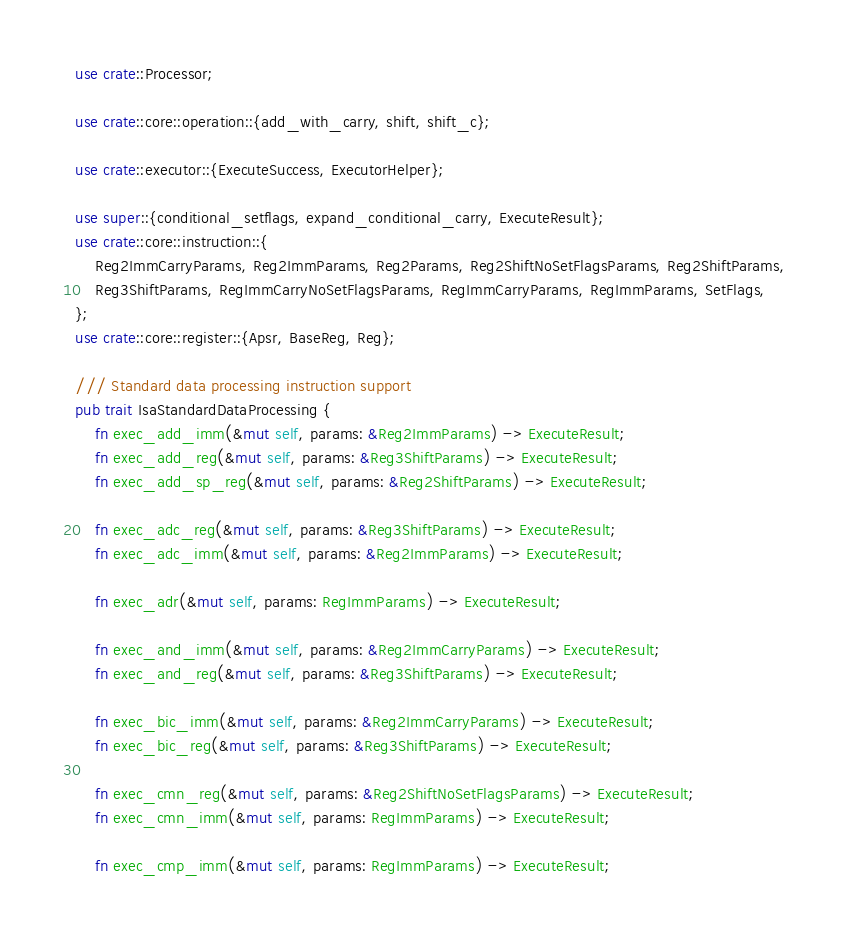<code> <loc_0><loc_0><loc_500><loc_500><_Rust_>use crate::Processor;

use crate::core::operation::{add_with_carry, shift, shift_c};

use crate::executor::{ExecuteSuccess, ExecutorHelper};

use super::{conditional_setflags, expand_conditional_carry, ExecuteResult};
use crate::core::instruction::{
    Reg2ImmCarryParams, Reg2ImmParams, Reg2Params, Reg2ShiftNoSetFlagsParams, Reg2ShiftParams,
    Reg3ShiftParams, RegImmCarryNoSetFlagsParams, RegImmCarryParams, RegImmParams, SetFlags,
};
use crate::core::register::{Apsr, BaseReg, Reg};

/// Standard data processing instruction support
pub trait IsaStandardDataProcessing {
    fn exec_add_imm(&mut self, params: &Reg2ImmParams) -> ExecuteResult;
    fn exec_add_reg(&mut self, params: &Reg3ShiftParams) -> ExecuteResult;
    fn exec_add_sp_reg(&mut self, params: &Reg2ShiftParams) -> ExecuteResult;

    fn exec_adc_reg(&mut self, params: &Reg3ShiftParams) -> ExecuteResult;
    fn exec_adc_imm(&mut self, params: &Reg2ImmParams) -> ExecuteResult;

    fn exec_adr(&mut self, params: RegImmParams) -> ExecuteResult;

    fn exec_and_imm(&mut self, params: &Reg2ImmCarryParams) -> ExecuteResult;
    fn exec_and_reg(&mut self, params: &Reg3ShiftParams) -> ExecuteResult;

    fn exec_bic_imm(&mut self, params: &Reg2ImmCarryParams) -> ExecuteResult;
    fn exec_bic_reg(&mut self, params: &Reg3ShiftParams) -> ExecuteResult;

    fn exec_cmn_reg(&mut self, params: &Reg2ShiftNoSetFlagsParams) -> ExecuteResult;
    fn exec_cmn_imm(&mut self, params: RegImmParams) -> ExecuteResult;

    fn exec_cmp_imm(&mut self, params: RegImmParams) -> ExecuteResult;</code> 